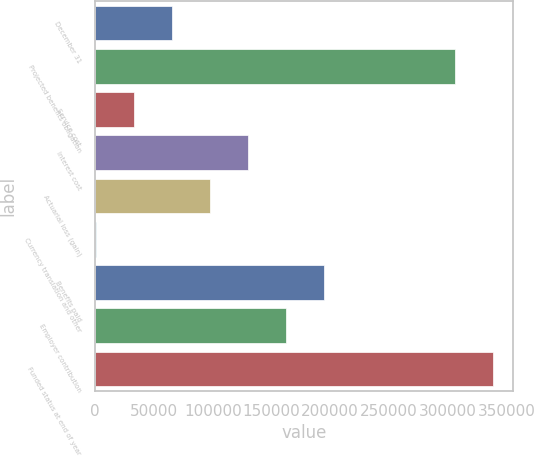Convert chart to OTSL. <chart><loc_0><loc_0><loc_500><loc_500><bar_chart><fcel>December 31<fcel>Projected benefits obligation<fcel>Service cost<fcel>Interest cost<fcel>Actuarial loss (gain)<fcel>Currency translation and other<fcel>Benefits paid<fcel>Employer contribution<fcel>Funded status at end of year<nl><fcel>65525<fcel>306300<fcel>33139<fcel>130297<fcel>97911<fcel>753<fcel>195069<fcel>162683<fcel>338686<nl></chart> 